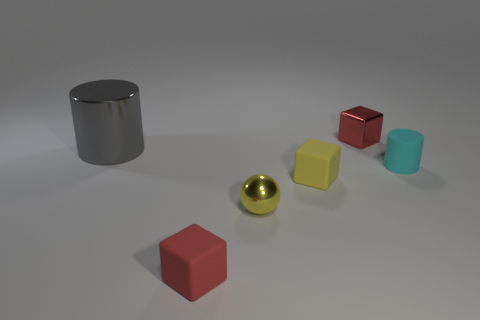Are the objects depicted capable of floating on water? From visual observation, it's not possible to conclude with certainty which objects can float without knowing their material composition. However, commonly, items like rubber balls tend to be buoyant. 